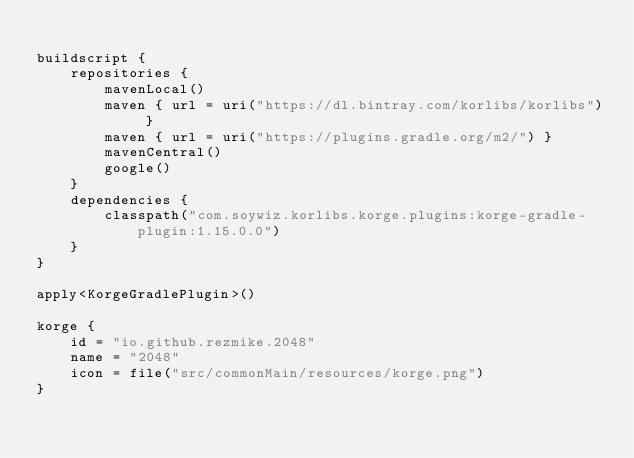<code> <loc_0><loc_0><loc_500><loc_500><_Kotlin_>
buildscript {
    repositories {
        mavenLocal()
        maven { url = uri("https://dl.bintray.com/korlibs/korlibs") }
        maven { url = uri("https://plugins.gradle.org/m2/") }
        mavenCentral()
        google()
    }
    dependencies {
        classpath("com.soywiz.korlibs.korge.plugins:korge-gradle-plugin:1.15.0.0")
    }
}

apply<KorgeGradlePlugin>()

korge {
    id = "io.github.rezmike.2048"
    name = "2048"
    icon = file("src/commonMain/resources/korge.png")
}
</code> 